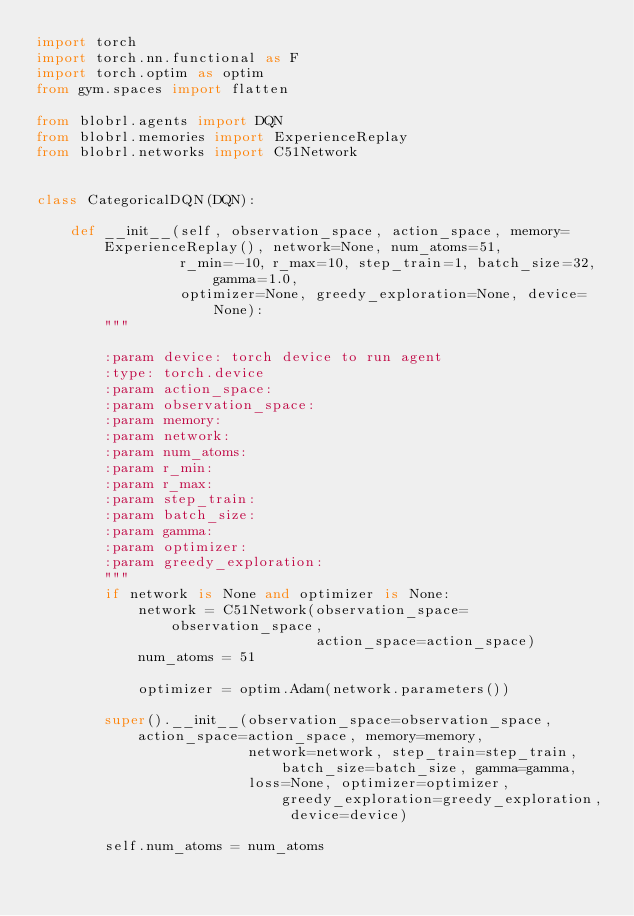<code> <loc_0><loc_0><loc_500><loc_500><_Python_>import torch
import torch.nn.functional as F
import torch.optim as optim
from gym.spaces import flatten

from blobrl.agents import DQN
from blobrl.memories import ExperienceReplay
from blobrl.networks import C51Network


class CategoricalDQN(DQN):

    def __init__(self, observation_space, action_space, memory=ExperienceReplay(), network=None, num_atoms=51,
                 r_min=-10, r_max=10, step_train=1, batch_size=32, gamma=1.0,
                 optimizer=None, greedy_exploration=None, device=None):
        """

        :param device: torch device to run agent
        :type: torch.device
        :param action_space:
        :param observation_space:
        :param memory:
        :param network:
        :param num_atoms:
        :param r_min:
        :param r_max:
        :param step_train:
        :param batch_size:
        :param gamma:
        :param optimizer:
        :param greedy_exploration:
        """
        if network is None and optimizer is None:
            network = C51Network(observation_space=observation_space,
                                 action_space=action_space)
            num_atoms = 51

            optimizer = optim.Adam(network.parameters())

        super().__init__(observation_space=observation_space, action_space=action_space, memory=memory,
                         network=network, step_train=step_train, batch_size=batch_size, gamma=gamma,
                         loss=None, optimizer=optimizer, greedy_exploration=greedy_exploration, device=device)

        self.num_atoms = num_atoms</code> 